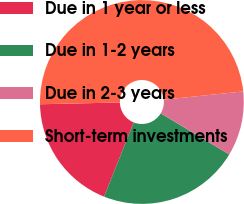Convert chart. <chart><loc_0><loc_0><loc_500><loc_500><pie_chart><fcel>Due in 1 year or less<fcel>Due in 1-2 years<fcel>Due in 2-3 years<fcel>Short-term investments<nl><fcel>18.6%<fcel>22.44%<fcel>10.26%<fcel>48.7%<nl></chart> 